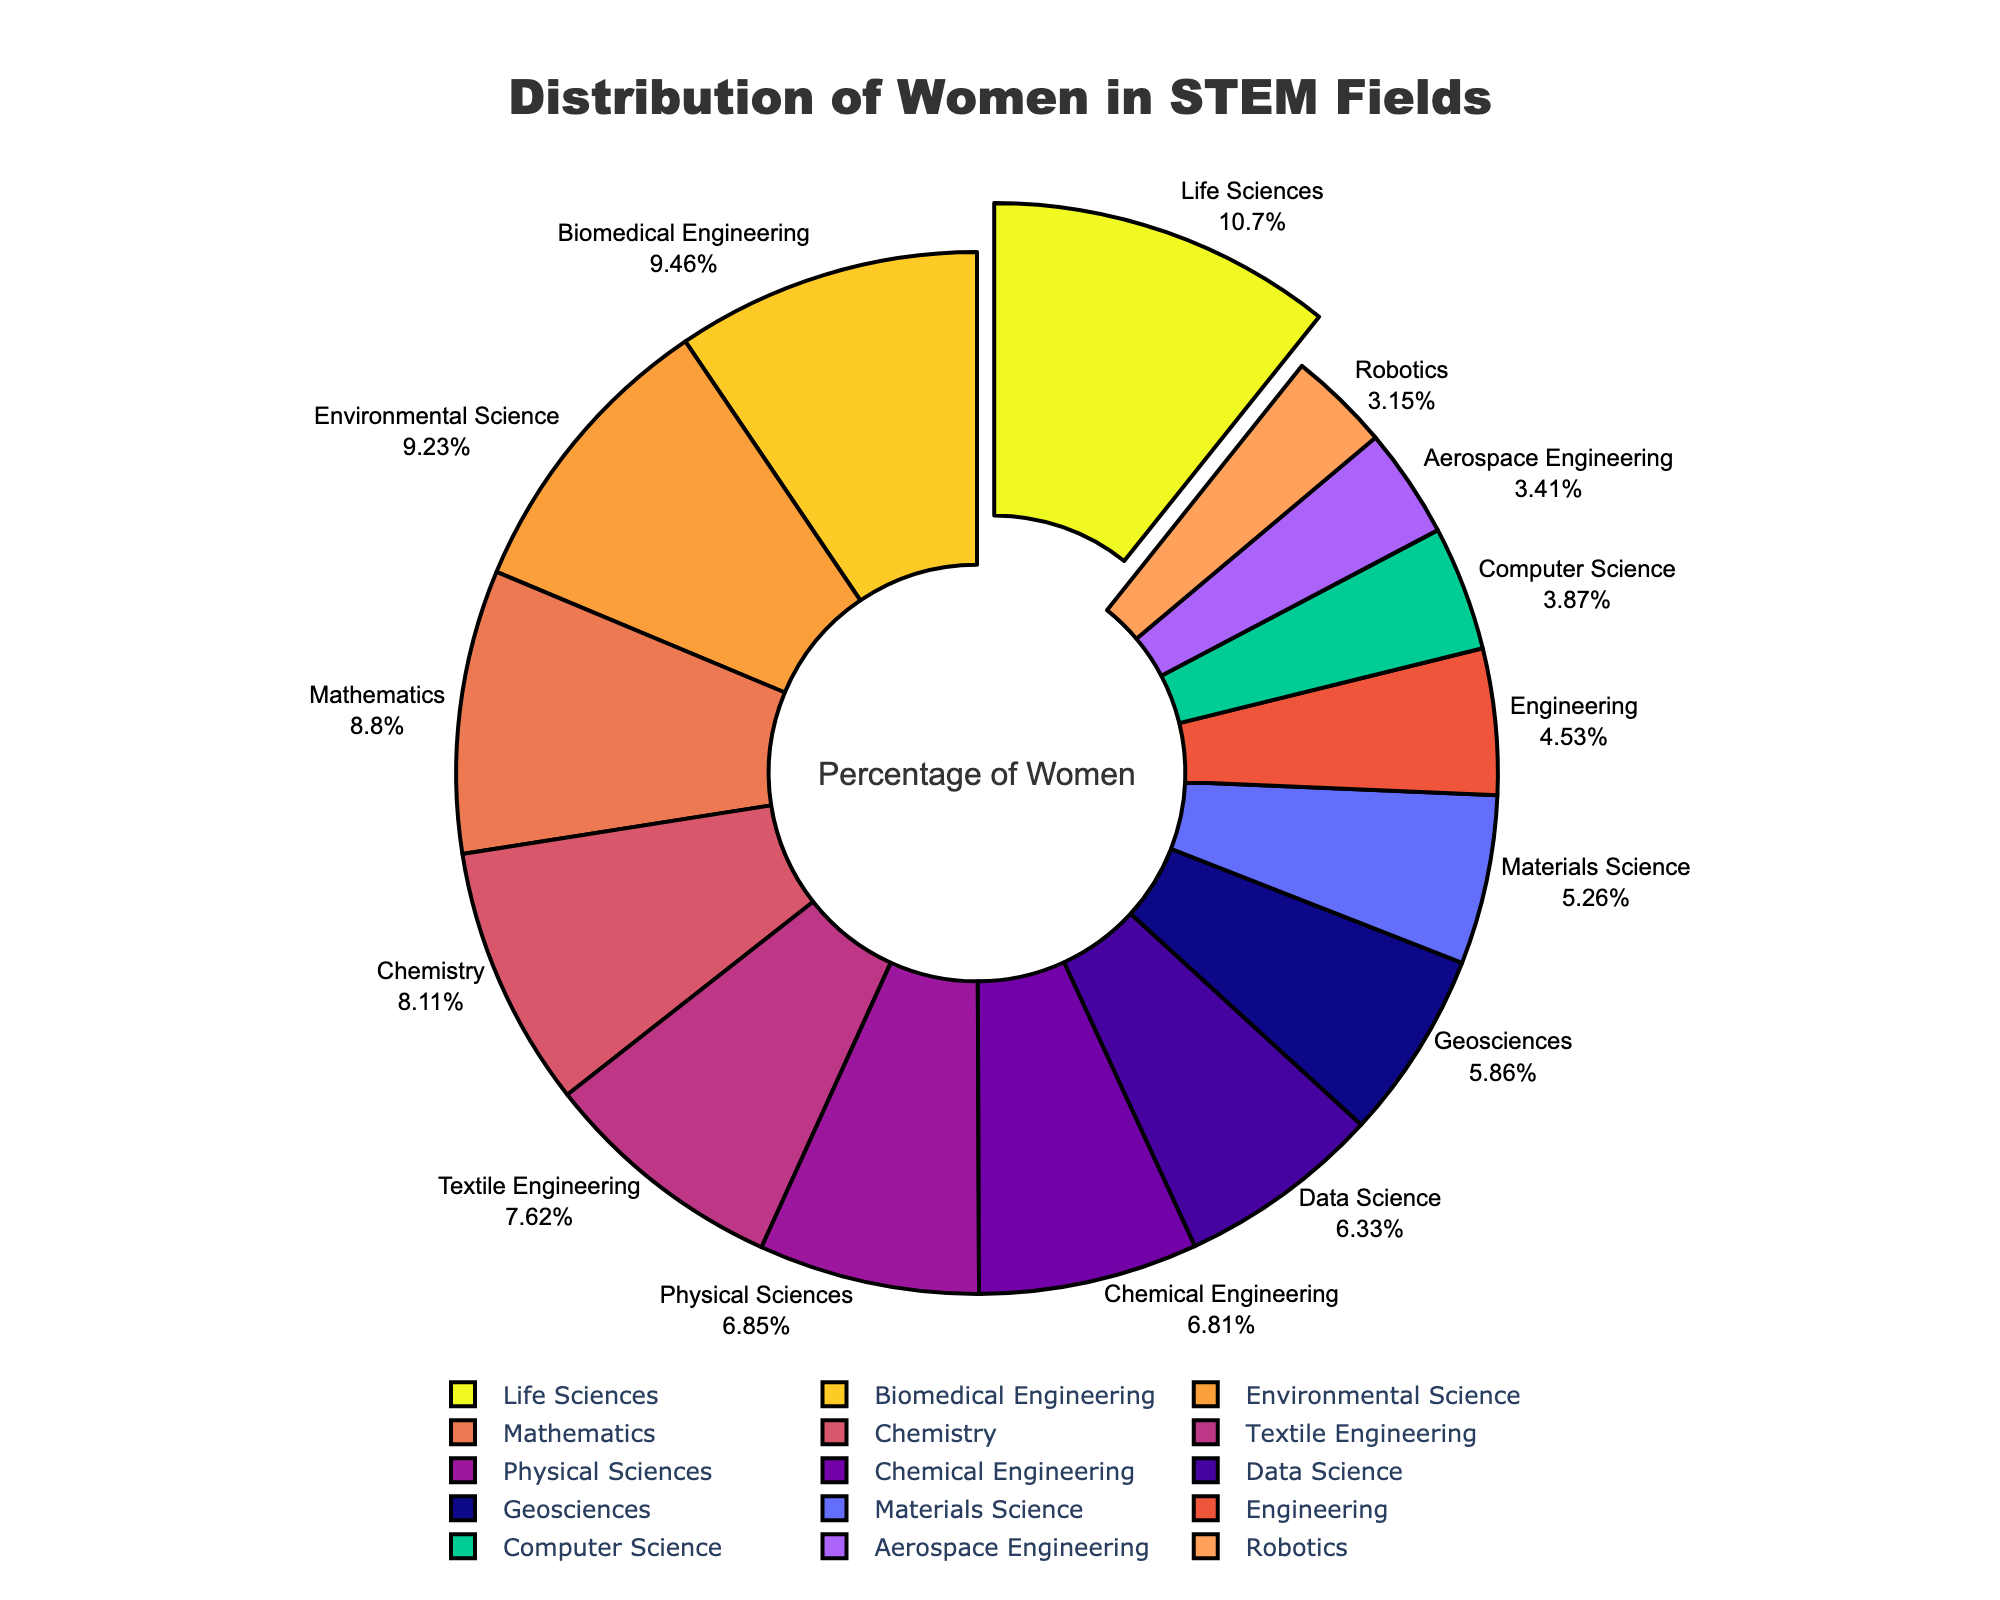What percentage of women are involved in Life Sciences? Locate the "Life Sciences" label on the pie chart and read the corresponding percentage next to it.
Answer: 51.8% Which field has the highest percentage of women involved? Identify the segment of the pie chart that is pulled out and check its label for the corresponding field.
Answer: Life Sciences How much more is the percentage of women in Mathematics compared to Data Science? Find and compare the percentages of Mathematics (42.5%) and Data Science (30.6%), then calculate the difference: 42.5 - 30.6 = 11.9.
Answer: 11.9% What is the average percentage of women in Chemistry, Chemical Engineering, and Materials Science? Sum the percentages of Chemistry (39.2%), Chemical Engineering (32.9%), and Materials Science (25.4%) and divide by 3: (39.2 + 32.9 + 25.4) / 3 = 32.5.
Answer: 32.5% Are there more women in Biomedical Engineering or in Engineering? Compare the percentages of Biomedical Engineering (45.7%) and Engineering (21.9%). Biomedical Engineering has a higher percentage.
Answer: Biomedical Engineering Which two fields have the closest percentage of women involved? Identify fields with the closest percentages by visually comparing neighboring segments on the pie chart: Chemical Engineering (32.9%) and Physical Sciences (33.1%) are very close.
Answer: Chemical Engineering and Physical Sciences What is the total percentage of women in Aerospace Engineering and Robotics? Add the percentages of Aerospace Engineering (16.5%) and Robotics (15.2%): 16.5 + 15.2 = 31.7.
Answer: 31.7% Is the percentage of women in Geosciences greater than in Textile Engineering? Compare the percentages of Geosciences (28.3%) and Textile Engineering (36.8%). Textile Engineering has a higher percentage.
Answer: No Which field has a higher percentage of women involved, Computer Science or Mathematics? Compare the percentages of Computer Science (18.7%) and Mathematics (42.5%). Mathematics has a higher percentage.
Answer: Mathematics 